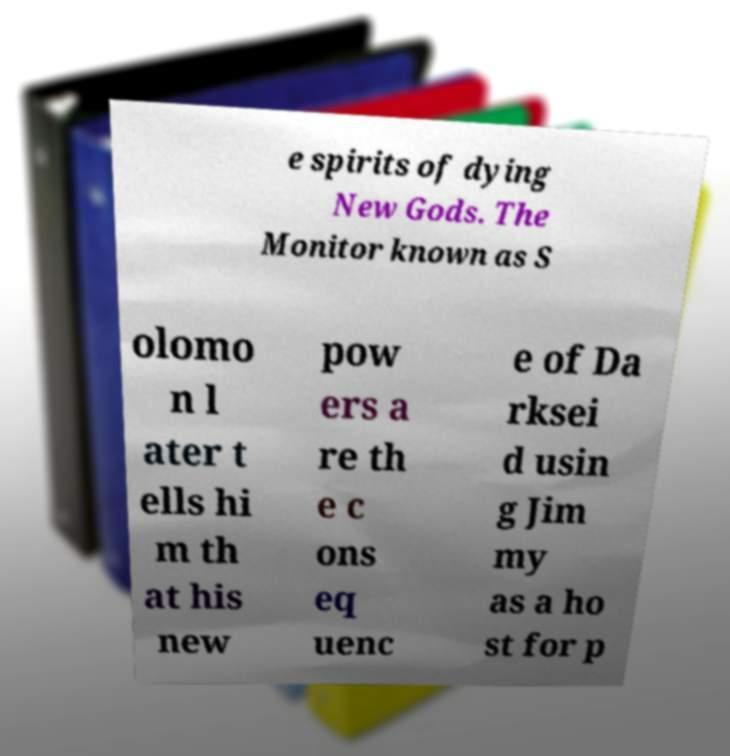Please read and relay the text visible in this image. What does it say? e spirits of dying New Gods. The Monitor known as S olomo n l ater t ells hi m th at his new pow ers a re th e c ons eq uenc e of Da rksei d usin g Jim my as a ho st for p 